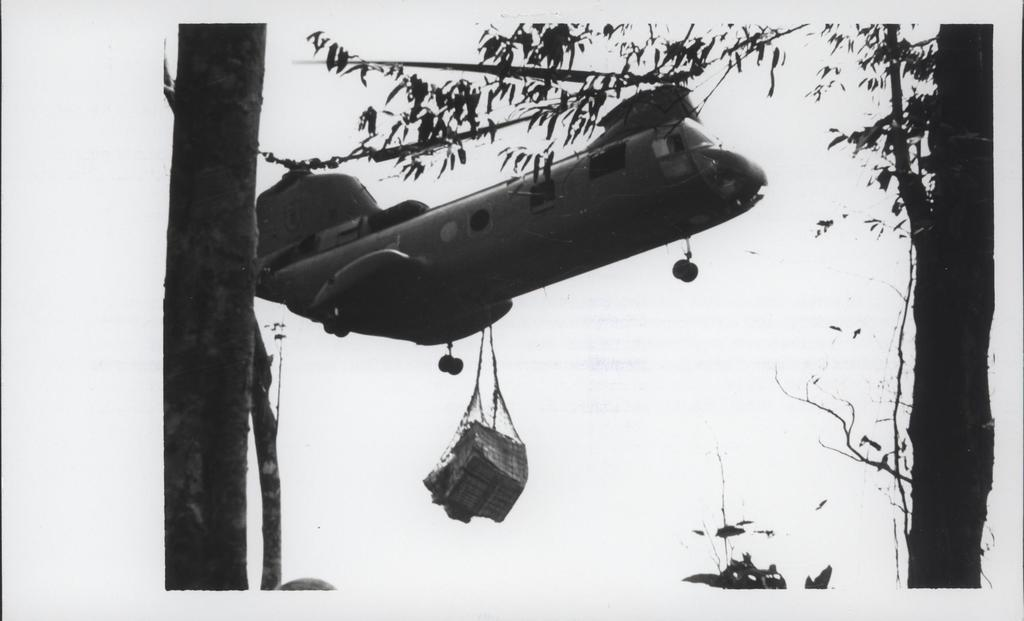What is the color scheme of the image? The image is black and white. What is the main subject of the image? There is an aircraft in the image. What is attached to the aircraft in the image? There is luggage hanging on the aircraft. What type of natural scenery can be seen in the image? There are trees visible in the image. What type of wine is being served in the image? There is no wine present in the image; it features an aircraft with luggage and trees in the background. 